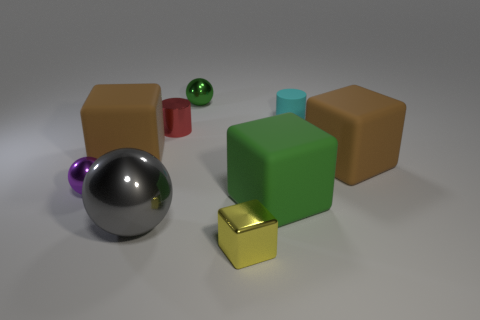Is the material of the big sphere the same as the cyan cylinder?
Ensure brevity in your answer.  No. What number of other things are the same size as the purple metallic sphere?
Make the answer very short. 4. There is a brown block that is on the left side of the sphere that is in front of the big green matte thing; what size is it?
Give a very brief answer. Large. There is a tiny matte cylinder that is to the right of the small ball in front of the brown block that is to the right of the green shiny object; what color is it?
Make the answer very short. Cyan. There is a object that is both behind the red cylinder and on the left side of the tiny rubber thing; how big is it?
Your answer should be compact. Small. How many other things are the same shape as the gray thing?
Provide a short and direct response. 2. How many cubes are either large things or gray metallic things?
Your answer should be very brief. 3. Is there a matte thing that is behind the brown rubber cube that is on the right side of the tiny yellow object that is on the right side of the gray shiny ball?
Keep it short and to the point. Yes. The other small shiny thing that is the same shape as the purple thing is what color?
Your answer should be very brief. Green. How many gray things are tiny rubber cylinders or large shiny objects?
Give a very brief answer. 1. 